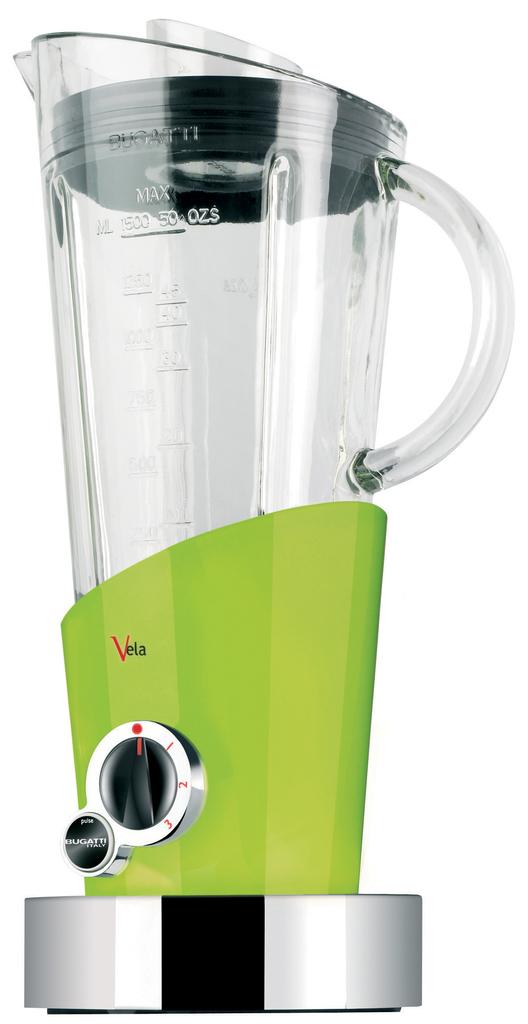What is the brand of the blender?
Provide a succinct answer. Vela. 